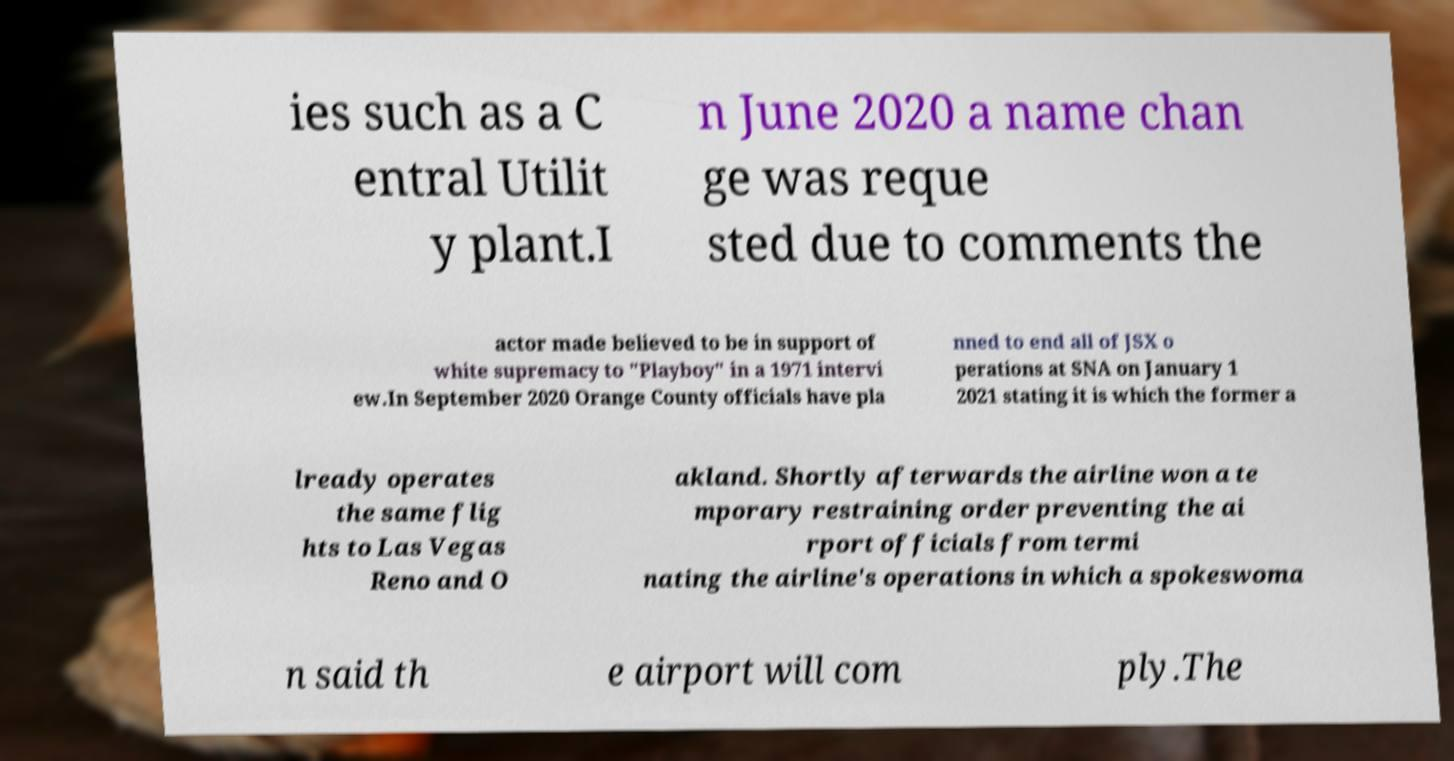Could you extract and type out the text from this image? ies such as a C entral Utilit y plant.I n June 2020 a name chan ge was reque sted due to comments the actor made believed to be in support of white supremacy to "Playboy" in a 1971 intervi ew.In September 2020 Orange County officials have pla nned to end all of JSX o perations at SNA on January 1 2021 stating it is which the former a lready operates the same flig hts to Las Vegas Reno and O akland. Shortly afterwards the airline won a te mporary restraining order preventing the ai rport officials from termi nating the airline's operations in which a spokeswoma n said th e airport will com ply.The 